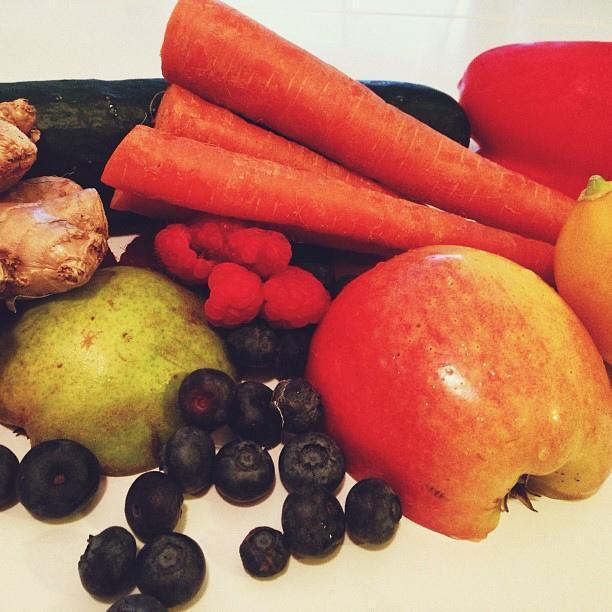How many carrots are in the photo?
Give a very brief answer. 3. 